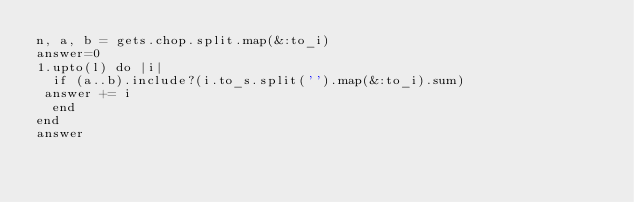<code> <loc_0><loc_0><loc_500><loc_500><_Ruby_>n, a, b = gets.chop.split.map(&:to_i)
answer=0
1.upto(l) do |i|
  if (a..b).include?(i.to_s.split('').map(&:to_i).sum)
 answer += i
  end
end
answer</code> 